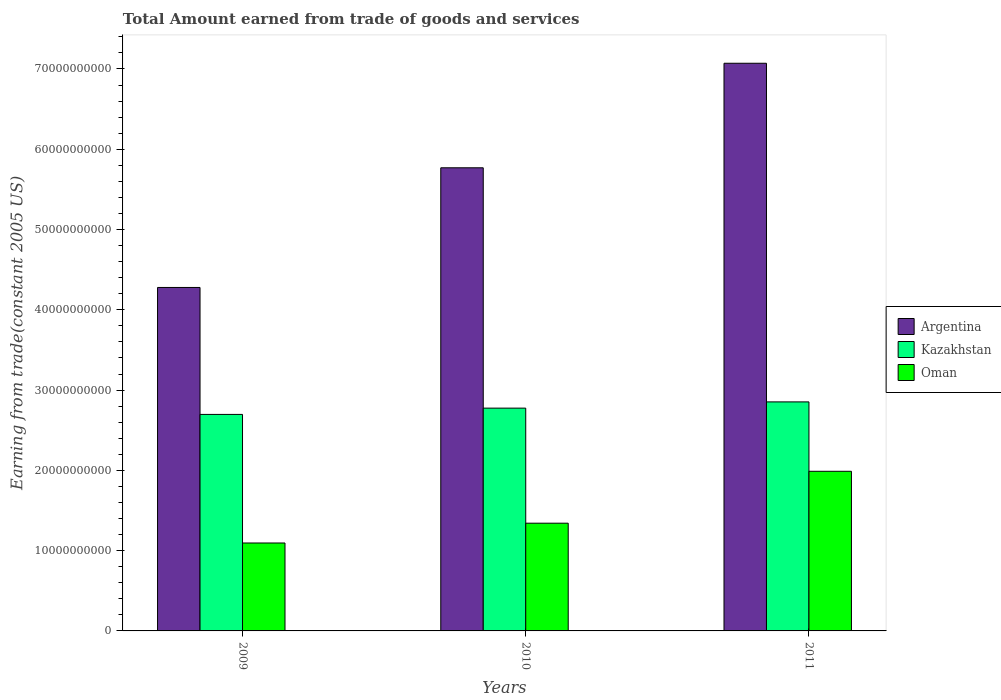How many different coloured bars are there?
Keep it short and to the point. 3. Are the number of bars per tick equal to the number of legend labels?
Your answer should be compact. Yes. In how many cases, is the number of bars for a given year not equal to the number of legend labels?
Your response must be concise. 0. What is the total amount earned by trading goods and services in Kazakhstan in 2010?
Offer a terse response. 2.78e+1. Across all years, what is the maximum total amount earned by trading goods and services in Oman?
Provide a short and direct response. 1.99e+1. Across all years, what is the minimum total amount earned by trading goods and services in Argentina?
Ensure brevity in your answer.  4.28e+1. In which year was the total amount earned by trading goods and services in Kazakhstan maximum?
Ensure brevity in your answer.  2011. What is the total total amount earned by trading goods and services in Oman in the graph?
Provide a succinct answer. 4.43e+1. What is the difference between the total amount earned by trading goods and services in Oman in 2009 and that in 2011?
Give a very brief answer. -8.93e+09. What is the difference between the total amount earned by trading goods and services in Argentina in 2011 and the total amount earned by trading goods and services in Kazakhstan in 2010?
Make the answer very short. 4.30e+1. What is the average total amount earned by trading goods and services in Kazakhstan per year?
Your answer should be compact. 2.77e+1. In the year 2011, what is the difference between the total amount earned by trading goods and services in Argentina and total amount earned by trading goods and services in Oman?
Your answer should be compact. 5.08e+1. What is the ratio of the total amount earned by trading goods and services in Argentina in 2009 to that in 2011?
Make the answer very short. 0.61. Is the difference between the total amount earned by trading goods and services in Argentina in 2010 and 2011 greater than the difference between the total amount earned by trading goods and services in Oman in 2010 and 2011?
Provide a short and direct response. No. What is the difference between the highest and the second highest total amount earned by trading goods and services in Argentina?
Keep it short and to the point. 1.30e+1. What is the difference between the highest and the lowest total amount earned by trading goods and services in Kazakhstan?
Provide a succinct answer. 1.56e+09. In how many years, is the total amount earned by trading goods and services in Kazakhstan greater than the average total amount earned by trading goods and services in Kazakhstan taken over all years?
Offer a very short reply. 2. What does the 2nd bar from the left in 2009 represents?
Your response must be concise. Kazakhstan. What does the 2nd bar from the right in 2011 represents?
Your response must be concise. Kazakhstan. Is it the case that in every year, the sum of the total amount earned by trading goods and services in Kazakhstan and total amount earned by trading goods and services in Argentina is greater than the total amount earned by trading goods and services in Oman?
Your response must be concise. Yes. How many bars are there?
Your answer should be very brief. 9. Are all the bars in the graph horizontal?
Provide a short and direct response. No. What is the difference between two consecutive major ticks on the Y-axis?
Provide a short and direct response. 1.00e+1. Are the values on the major ticks of Y-axis written in scientific E-notation?
Your answer should be compact. No. Does the graph contain grids?
Offer a terse response. No. Where does the legend appear in the graph?
Keep it short and to the point. Center right. What is the title of the graph?
Make the answer very short. Total Amount earned from trade of goods and services. Does "Slovenia" appear as one of the legend labels in the graph?
Offer a very short reply. No. What is the label or title of the Y-axis?
Make the answer very short. Earning from trade(constant 2005 US). What is the Earning from trade(constant 2005 US) in Argentina in 2009?
Your answer should be compact. 4.28e+1. What is the Earning from trade(constant 2005 US) of Kazakhstan in 2009?
Your answer should be very brief. 2.70e+1. What is the Earning from trade(constant 2005 US) of Oman in 2009?
Provide a succinct answer. 1.10e+1. What is the Earning from trade(constant 2005 US) in Argentina in 2010?
Make the answer very short. 5.77e+1. What is the Earning from trade(constant 2005 US) in Kazakhstan in 2010?
Your answer should be very brief. 2.78e+1. What is the Earning from trade(constant 2005 US) in Oman in 2010?
Your response must be concise. 1.34e+1. What is the Earning from trade(constant 2005 US) of Argentina in 2011?
Keep it short and to the point. 7.07e+1. What is the Earning from trade(constant 2005 US) of Kazakhstan in 2011?
Your answer should be very brief. 2.85e+1. What is the Earning from trade(constant 2005 US) of Oman in 2011?
Keep it short and to the point. 1.99e+1. Across all years, what is the maximum Earning from trade(constant 2005 US) in Argentina?
Ensure brevity in your answer.  7.07e+1. Across all years, what is the maximum Earning from trade(constant 2005 US) of Kazakhstan?
Provide a succinct answer. 2.85e+1. Across all years, what is the maximum Earning from trade(constant 2005 US) of Oman?
Offer a terse response. 1.99e+1. Across all years, what is the minimum Earning from trade(constant 2005 US) in Argentina?
Provide a succinct answer. 4.28e+1. Across all years, what is the minimum Earning from trade(constant 2005 US) of Kazakhstan?
Your answer should be compact. 2.70e+1. Across all years, what is the minimum Earning from trade(constant 2005 US) in Oman?
Provide a short and direct response. 1.10e+1. What is the total Earning from trade(constant 2005 US) of Argentina in the graph?
Ensure brevity in your answer.  1.71e+11. What is the total Earning from trade(constant 2005 US) of Kazakhstan in the graph?
Ensure brevity in your answer.  8.32e+1. What is the total Earning from trade(constant 2005 US) in Oman in the graph?
Offer a terse response. 4.43e+1. What is the difference between the Earning from trade(constant 2005 US) in Argentina in 2009 and that in 2010?
Offer a terse response. -1.49e+1. What is the difference between the Earning from trade(constant 2005 US) in Kazakhstan in 2009 and that in 2010?
Provide a short and direct response. -7.82e+08. What is the difference between the Earning from trade(constant 2005 US) of Oman in 2009 and that in 2010?
Your answer should be compact. -2.47e+09. What is the difference between the Earning from trade(constant 2005 US) of Argentina in 2009 and that in 2011?
Your answer should be very brief. -2.79e+1. What is the difference between the Earning from trade(constant 2005 US) of Kazakhstan in 2009 and that in 2011?
Offer a very short reply. -1.56e+09. What is the difference between the Earning from trade(constant 2005 US) in Oman in 2009 and that in 2011?
Make the answer very short. -8.93e+09. What is the difference between the Earning from trade(constant 2005 US) in Argentina in 2010 and that in 2011?
Keep it short and to the point. -1.30e+1. What is the difference between the Earning from trade(constant 2005 US) of Kazakhstan in 2010 and that in 2011?
Provide a succinct answer. -7.77e+08. What is the difference between the Earning from trade(constant 2005 US) of Oman in 2010 and that in 2011?
Make the answer very short. -6.46e+09. What is the difference between the Earning from trade(constant 2005 US) of Argentina in 2009 and the Earning from trade(constant 2005 US) of Kazakhstan in 2010?
Your response must be concise. 1.50e+1. What is the difference between the Earning from trade(constant 2005 US) in Argentina in 2009 and the Earning from trade(constant 2005 US) in Oman in 2010?
Make the answer very short. 2.94e+1. What is the difference between the Earning from trade(constant 2005 US) of Kazakhstan in 2009 and the Earning from trade(constant 2005 US) of Oman in 2010?
Ensure brevity in your answer.  1.36e+1. What is the difference between the Earning from trade(constant 2005 US) in Argentina in 2009 and the Earning from trade(constant 2005 US) in Kazakhstan in 2011?
Provide a short and direct response. 1.43e+1. What is the difference between the Earning from trade(constant 2005 US) in Argentina in 2009 and the Earning from trade(constant 2005 US) in Oman in 2011?
Provide a short and direct response. 2.29e+1. What is the difference between the Earning from trade(constant 2005 US) in Kazakhstan in 2009 and the Earning from trade(constant 2005 US) in Oman in 2011?
Provide a succinct answer. 7.09e+09. What is the difference between the Earning from trade(constant 2005 US) of Argentina in 2010 and the Earning from trade(constant 2005 US) of Kazakhstan in 2011?
Offer a terse response. 2.92e+1. What is the difference between the Earning from trade(constant 2005 US) of Argentina in 2010 and the Earning from trade(constant 2005 US) of Oman in 2011?
Your response must be concise. 3.78e+1. What is the difference between the Earning from trade(constant 2005 US) of Kazakhstan in 2010 and the Earning from trade(constant 2005 US) of Oman in 2011?
Your answer should be compact. 7.87e+09. What is the average Earning from trade(constant 2005 US) in Argentina per year?
Keep it short and to the point. 5.71e+1. What is the average Earning from trade(constant 2005 US) of Kazakhstan per year?
Offer a very short reply. 2.77e+1. What is the average Earning from trade(constant 2005 US) of Oman per year?
Your response must be concise. 1.48e+1. In the year 2009, what is the difference between the Earning from trade(constant 2005 US) in Argentina and Earning from trade(constant 2005 US) in Kazakhstan?
Your answer should be compact. 1.58e+1. In the year 2009, what is the difference between the Earning from trade(constant 2005 US) in Argentina and Earning from trade(constant 2005 US) in Oman?
Your answer should be compact. 3.18e+1. In the year 2009, what is the difference between the Earning from trade(constant 2005 US) of Kazakhstan and Earning from trade(constant 2005 US) of Oman?
Offer a very short reply. 1.60e+1. In the year 2010, what is the difference between the Earning from trade(constant 2005 US) of Argentina and Earning from trade(constant 2005 US) of Kazakhstan?
Offer a terse response. 2.99e+1. In the year 2010, what is the difference between the Earning from trade(constant 2005 US) of Argentina and Earning from trade(constant 2005 US) of Oman?
Offer a terse response. 4.43e+1. In the year 2010, what is the difference between the Earning from trade(constant 2005 US) in Kazakhstan and Earning from trade(constant 2005 US) in Oman?
Your answer should be very brief. 1.43e+1. In the year 2011, what is the difference between the Earning from trade(constant 2005 US) in Argentina and Earning from trade(constant 2005 US) in Kazakhstan?
Ensure brevity in your answer.  4.22e+1. In the year 2011, what is the difference between the Earning from trade(constant 2005 US) of Argentina and Earning from trade(constant 2005 US) of Oman?
Make the answer very short. 5.08e+1. In the year 2011, what is the difference between the Earning from trade(constant 2005 US) of Kazakhstan and Earning from trade(constant 2005 US) of Oman?
Give a very brief answer. 8.65e+09. What is the ratio of the Earning from trade(constant 2005 US) in Argentina in 2009 to that in 2010?
Offer a very short reply. 0.74. What is the ratio of the Earning from trade(constant 2005 US) in Kazakhstan in 2009 to that in 2010?
Ensure brevity in your answer.  0.97. What is the ratio of the Earning from trade(constant 2005 US) of Oman in 2009 to that in 2010?
Provide a short and direct response. 0.82. What is the ratio of the Earning from trade(constant 2005 US) in Argentina in 2009 to that in 2011?
Provide a succinct answer. 0.61. What is the ratio of the Earning from trade(constant 2005 US) of Kazakhstan in 2009 to that in 2011?
Keep it short and to the point. 0.95. What is the ratio of the Earning from trade(constant 2005 US) of Oman in 2009 to that in 2011?
Offer a terse response. 0.55. What is the ratio of the Earning from trade(constant 2005 US) of Argentina in 2010 to that in 2011?
Provide a succinct answer. 0.82. What is the ratio of the Earning from trade(constant 2005 US) in Kazakhstan in 2010 to that in 2011?
Make the answer very short. 0.97. What is the ratio of the Earning from trade(constant 2005 US) of Oman in 2010 to that in 2011?
Keep it short and to the point. 0.67. What is the difference between the highest and the second highest Earning from trade(constant 2005 US) in Argentina?
Your answer should be very brief. 1.30e+1. What is the difference between the highest and the second highest Earning from trade(constant 2005 US) in Kazakhstan?
Keep it short and to the point. 7.77e+08. What is the difference between the highest and the second highest Earning from trade(constant 2005 US) in Oman?
Keep it short and to the point. 6.46e+09. What is the difference between the highest and the lowest Earning from trade(constant 2005 US) of Argentina?
Keep it short and to the point. 2.79e+1. What is the difference between the highest and the lowest Earning from trade(constant 2005 US) in Kazakhstan?
Offer a very short reply. 1.56e+09. What is the difference between the highest and the lowest Earning from trade(constant 2005 US) in Oman?
Your response must be concise. 8.93e+09. 